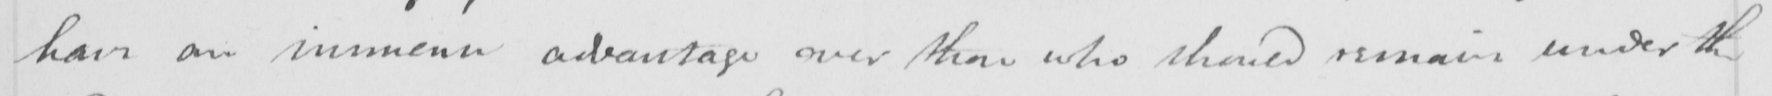Transcribe the text shown in this historical manuscript line. have an immense advantage over those who should remain under the 